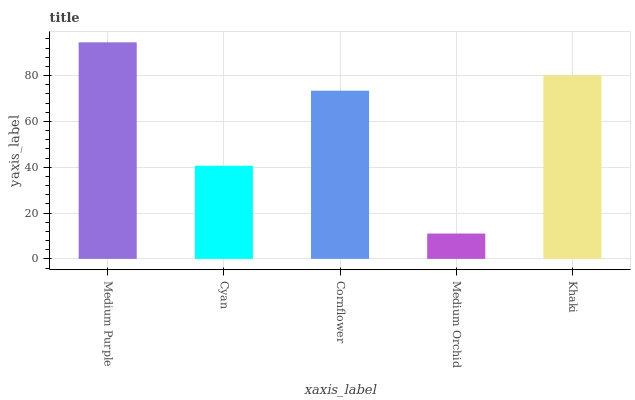Is Medium Orchid the minimum?
Answer yes or no. Yes. Is Medium Purple the maximum?
Answer yes or no. Yes. Is Cyan the minimum?
Answer yes or no. No. Is Cyan the maximum?
Answer yes or no. No. Is Medium Purple greater than Cyan?
Answer yes or no. Yes. Is Cyan less than Medium Purple?
Answer yes or no. Yes. Is Cyan greater than Medium Purple?
Answer yes or no. No. Is Medium Purple less than Cyan?
Answer yes or no. No. Is Cornflower the high median?
Answer yes or no. Yes. Is Cornflower the low median?
Answer yes or no. Yes. Is Medium Purple the high median?
Answer yes or no. No. Is Medium Purple the low median?
Answer yes or no. No. 